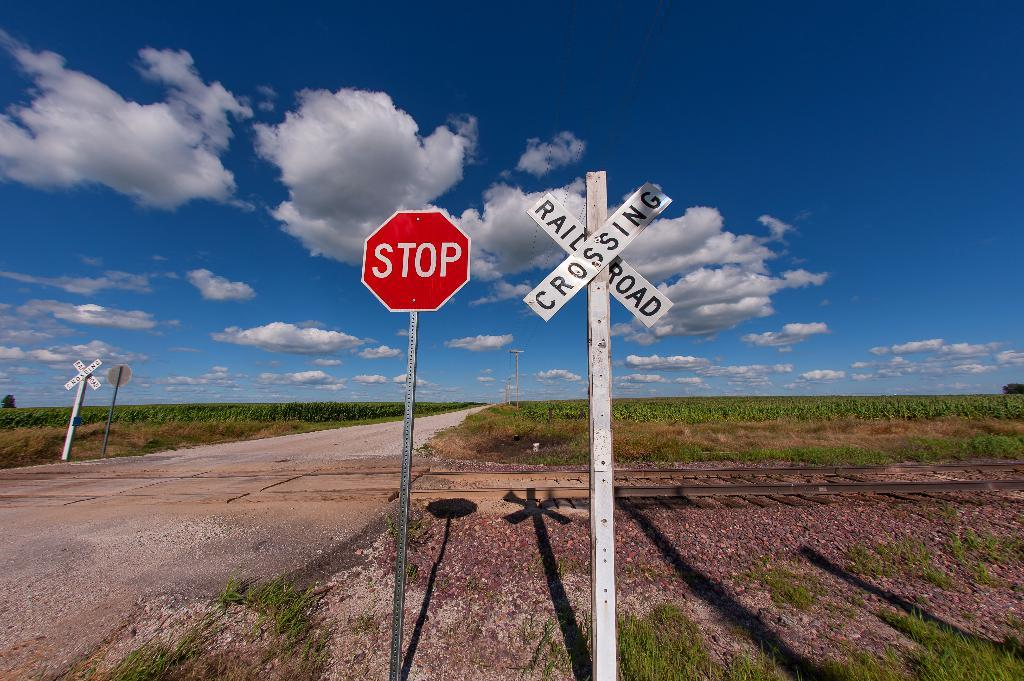<image>
Create a compact narrative representing the image presented. streetsigns with one that says 'stop' on it 